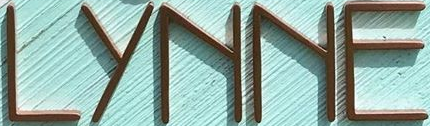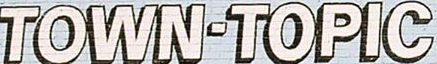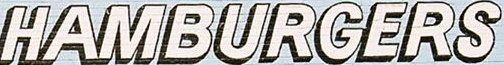What text appears in these images from left to right, separated by a semicolon? LYNNE; TOWN-TOPIC; HAMBURGERS 